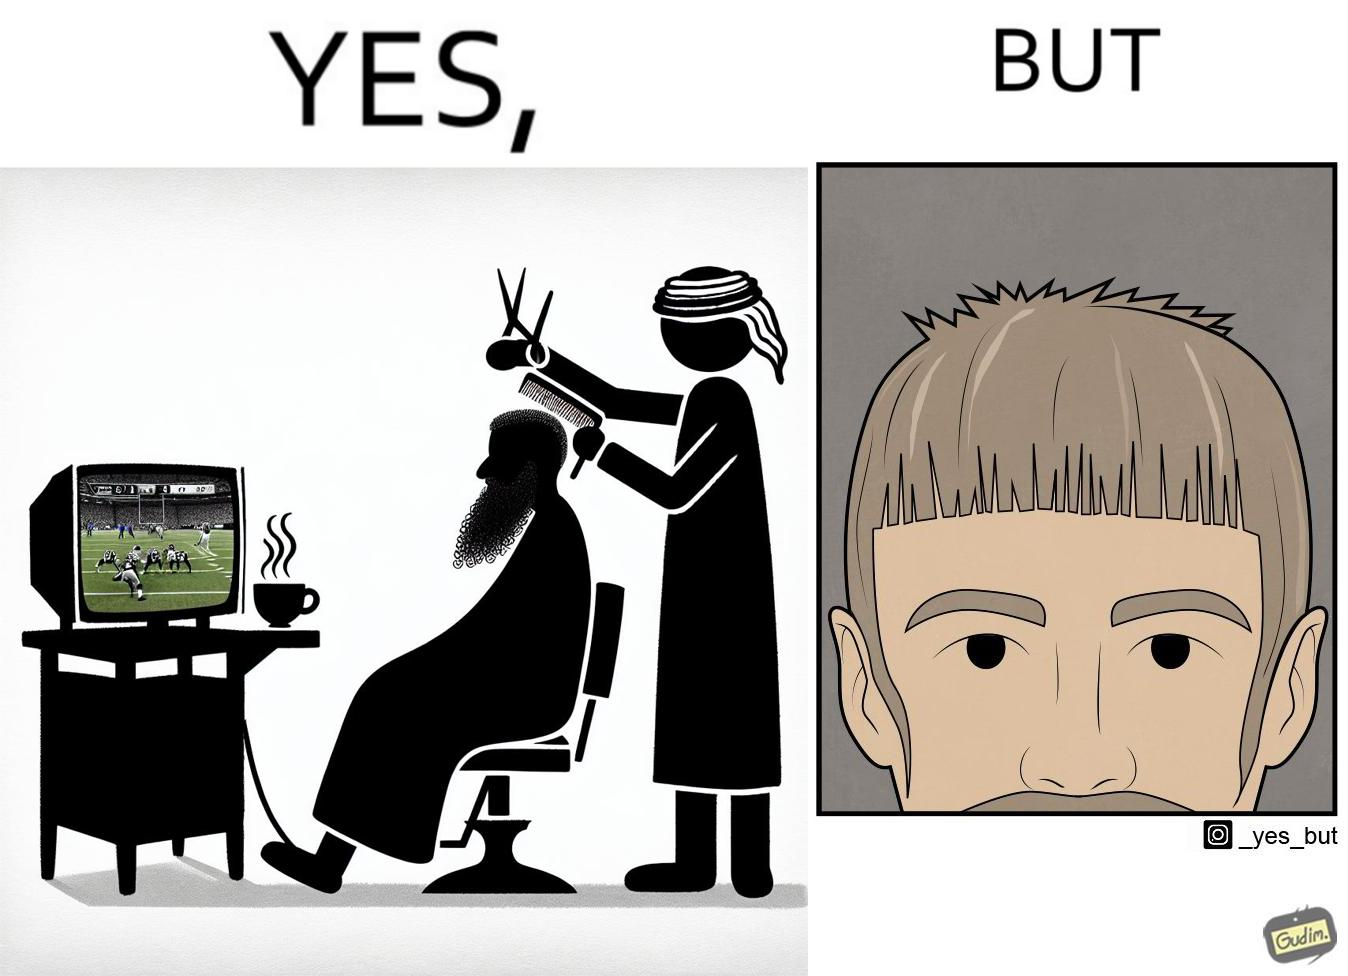Explain the humor or irony in this image. The image is ironic, because the sole purpose of the person was to get a hair cut but he became so much engrossed in the game that the barber wasn't able to cut his hairs properly. and even the saloon is providing so many facilities but they don't have a good hairdresser 